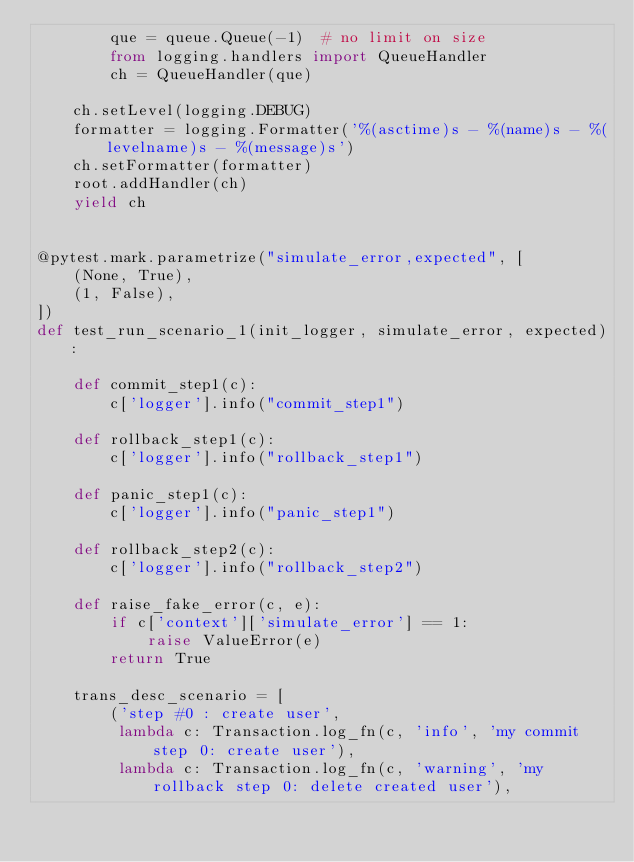<code> <loc_0><loc_0><loc_500><loc_500><_Python_>        que = queue.Queue(-1)  # no limit on size
        from logging.handlers import QueueHandler
        ch = QueueHandler(que)

    ch.setLevel(logging.DEBUG)
    formatter = logging.Formatter('%(asctime)s - %(name)s - %(levelname)s - %(message)s')
    ch.setFormatter(formatter)
    root.addHandler(ch)
    yield ch


@pytest.mark.parametrize("simulate_error,expected", [
    (None, True),
    (1, False),
])
def test_run_scenario_1(init_logger, simulate_error, expected):

    def commit_step1(c):
        c['logger'].info("commit_step1")

    def rollback_step1(c):
        c['logger'].info("rollback_step1")

    def panic_step1(c):
        c['logger'].info("panic_step1")

    def rollback_step2(c):
        c['logger'].info("rollback_step2")

    def raise_fake_error(c, e):
        if c['context']['simulate_error'] == 1:
            raise ValueError(e)
        return True

    trans_desc_scenario = [
        ('step #0 : create user',
         lambda c: Transaction.log_fn(c, 'info', 'my commit step 0: create user'),
         lambda c: Transaction.log_fn(c, 'warning', 'my rollback step 0: delete created user'),</code> 